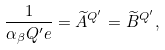Convert formula to latex. <formula><loc_0><loc_0><loc_500><loc_500>\frac { 1 } { \alpha _ { \beta } Q ^ { \prime } e } = \widetilde { A } ^ { Q ^ { \prime } } = \widetilde { B } ^ { Q ^ { \prime } } ,</formula> 